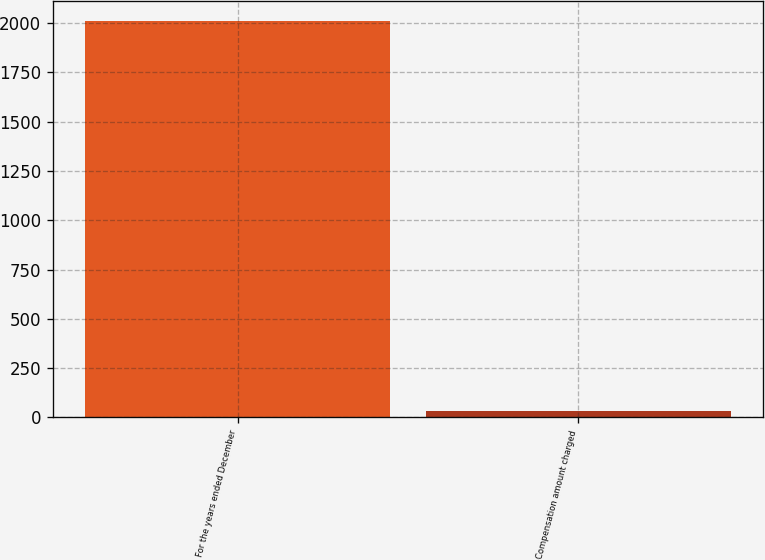Convert chart to OTSL. <chart><loc_0><loc_0><loc_500><loc_500><bar_chart><fcel>For the years ended December<fcel>Compensation amount charged<nl><fcel>2009<fcel>30<nl></chart> 